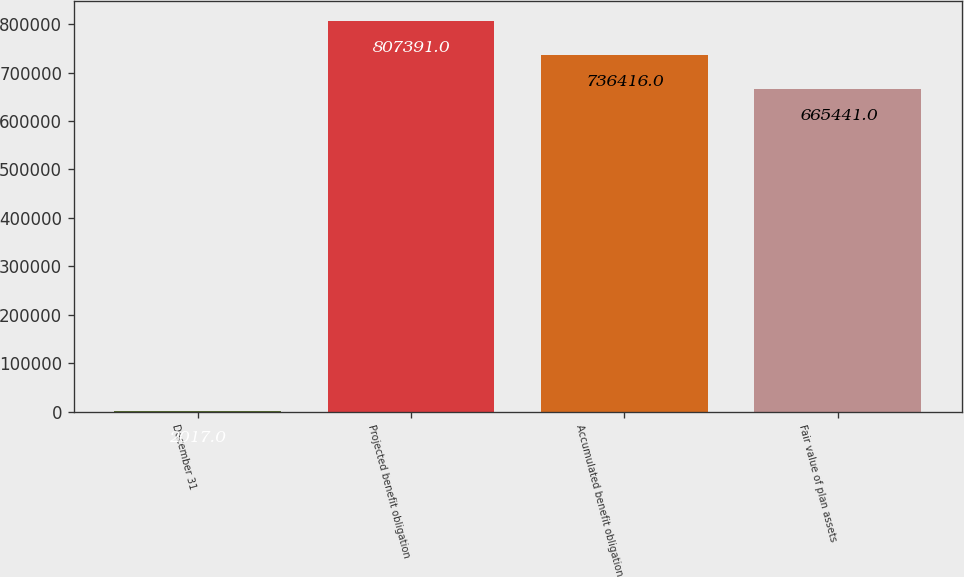Convert chart to OTSL. <chart><loc_0><loc_0><loc_500><loc_500><bar_chart><fcel>December 31<fcel>Projected benefit obligation<fcel>Accumulated benefit obligation<fcel>Fair value of plan assets<nl><fcel>2017<fcel>807391<fcel>736416<fcel>665441<nl></chart> 